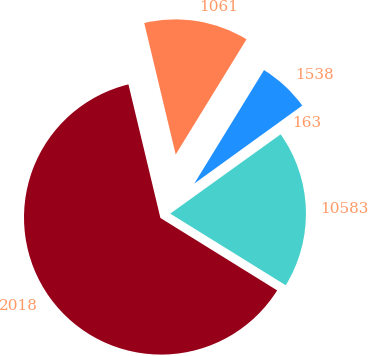<chart> <loc_0><loc_0><loc_500><loc_500><pie_chart><fcel>2018<fcel>10583<fcel>163<fcel>1538<fcel>1061<nl><fcel>62.42%<fcel>18.75%<fcel>0.04%<fcel>6.27%<fcel>12.51%<nl></chart> 